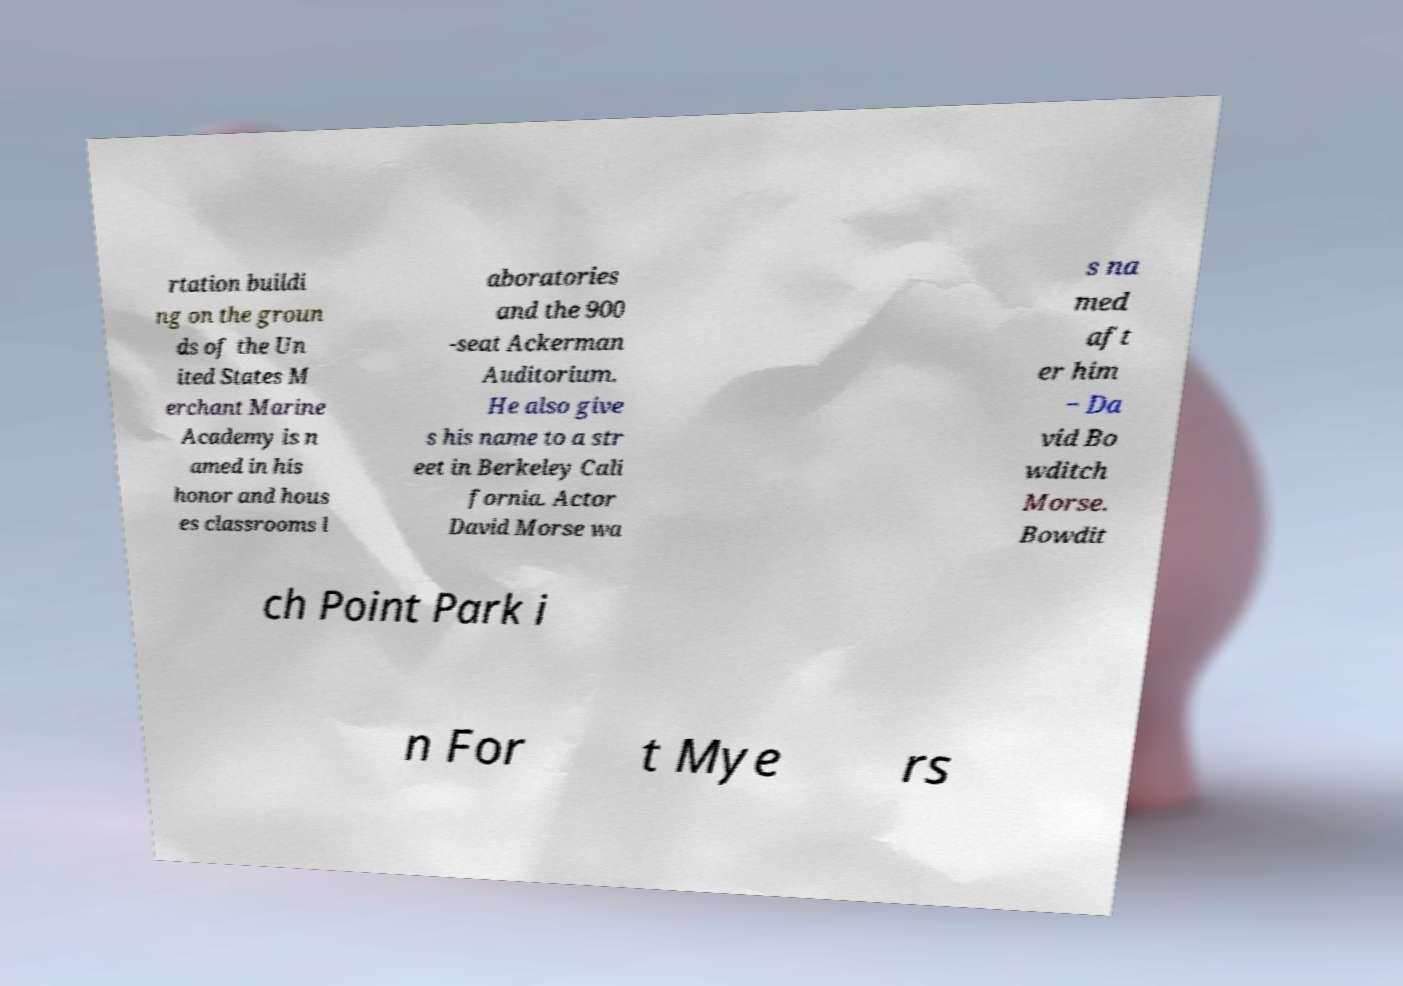There's text embedded in this image that I need extracted. Can you transcribe it verbatim? rtation buildi ng on the groun ds of the Un ited States M erchant Marine Academy is n amed in his honor and hous es classrooms l aboratories and the 900 -seat Ackerman Auditorium. He also give s his name to a str eet in Berkeley Cali fornia. Actor David Morse wa s na med aft er him − Da vid Bo wditch Morse. Bowdit ch Point Park i n For t Mye rs 